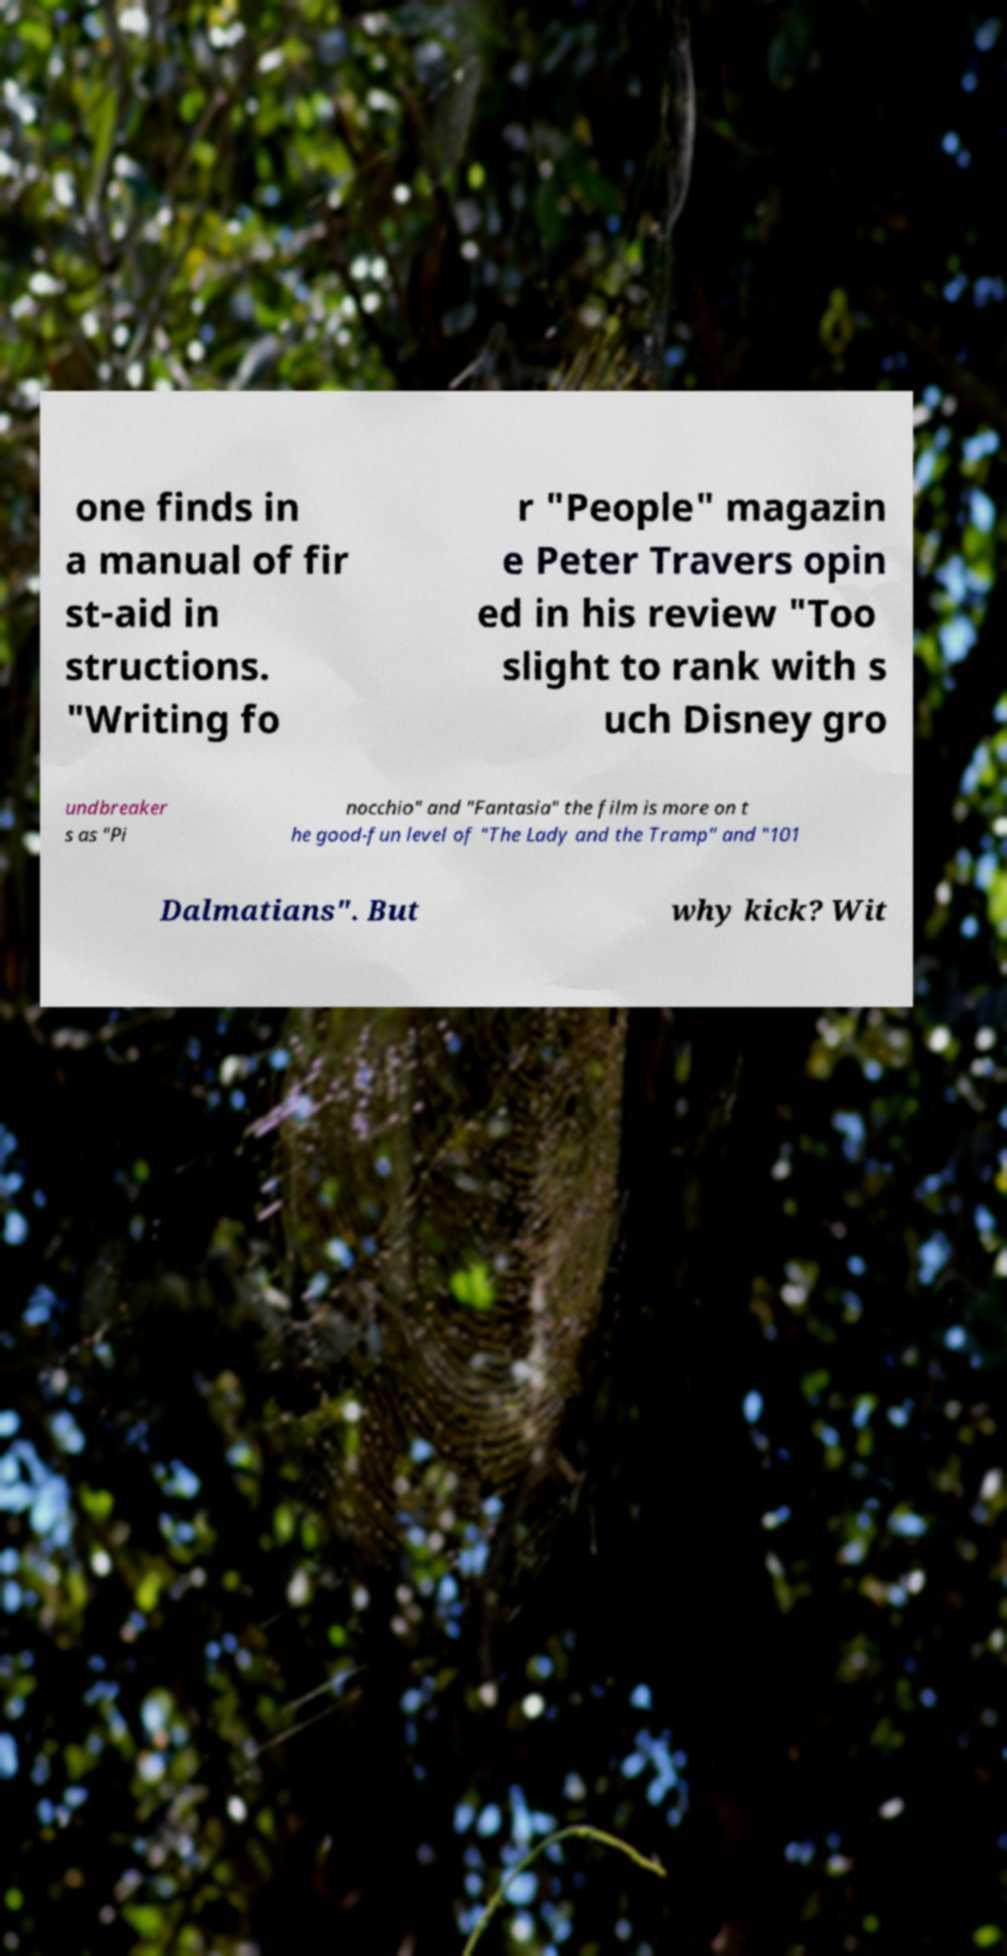I need the written content from this picture converted into text. Can you do that? one finds in a manual of fir st-aid in structions. "Writing fo r "People" magazin e Peter Travers opin ed in his review "Too slight to rank with s uch Disney gro undbreaker s as "Pi nocchio" and "Fantasia" the film is more on t he good-fun level of "The Lady and the Tramp" and "101 Dalmatians". But why kick? Wit 